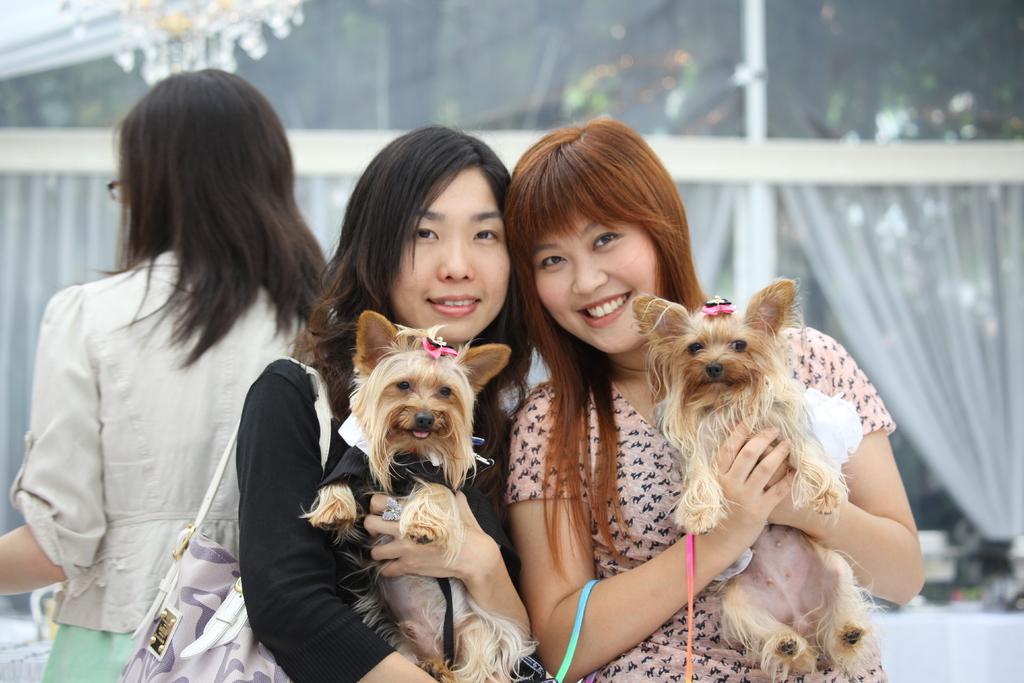Please provide a concise description of this image. There are two women holding two dogs in their hands. Both of them were smiling. Behind them there is another woman standing. In the background there are some curtains and glass doors here. 